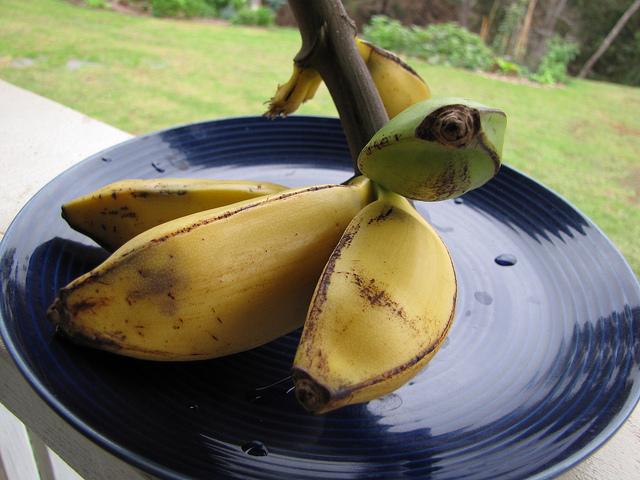Are these plantains?
Keep it brief. Yes. Was it taken outside?
Write a very short answer. Yes. Are these still on a branch?
Quick response, please. Yes. 